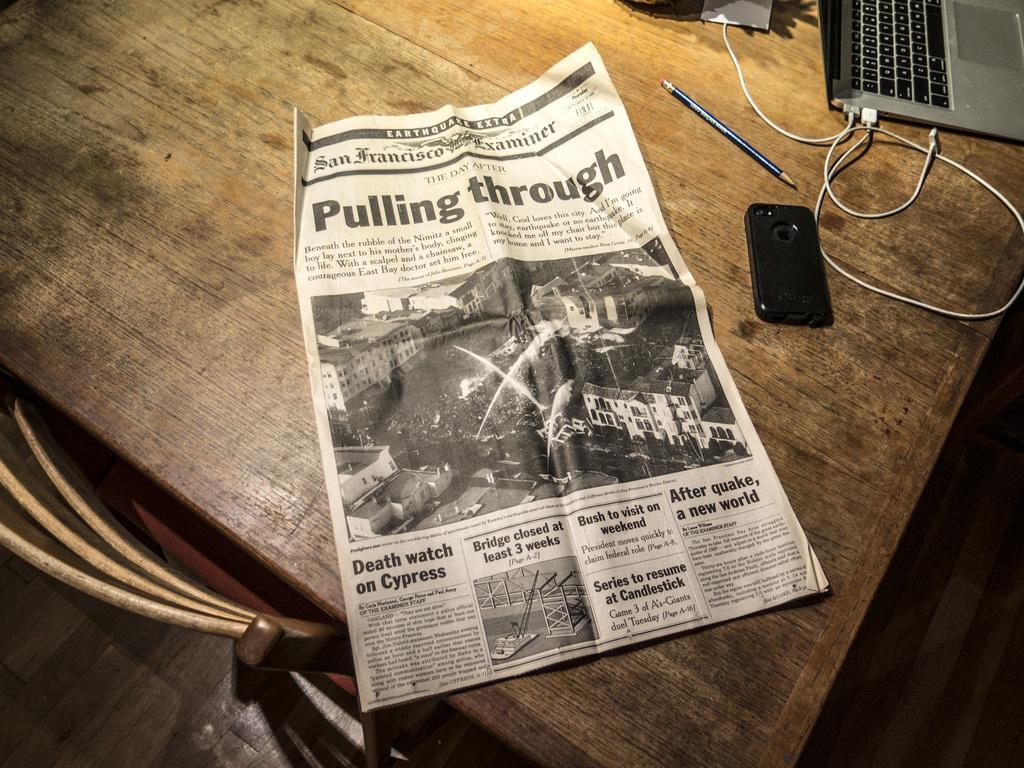What is the main headline on this newspaper?
Keep it short and to the point. Pulling through. What is the story title on the very bottom left of the newspaper?
Offer a very short reply. Death watch on cypress. 